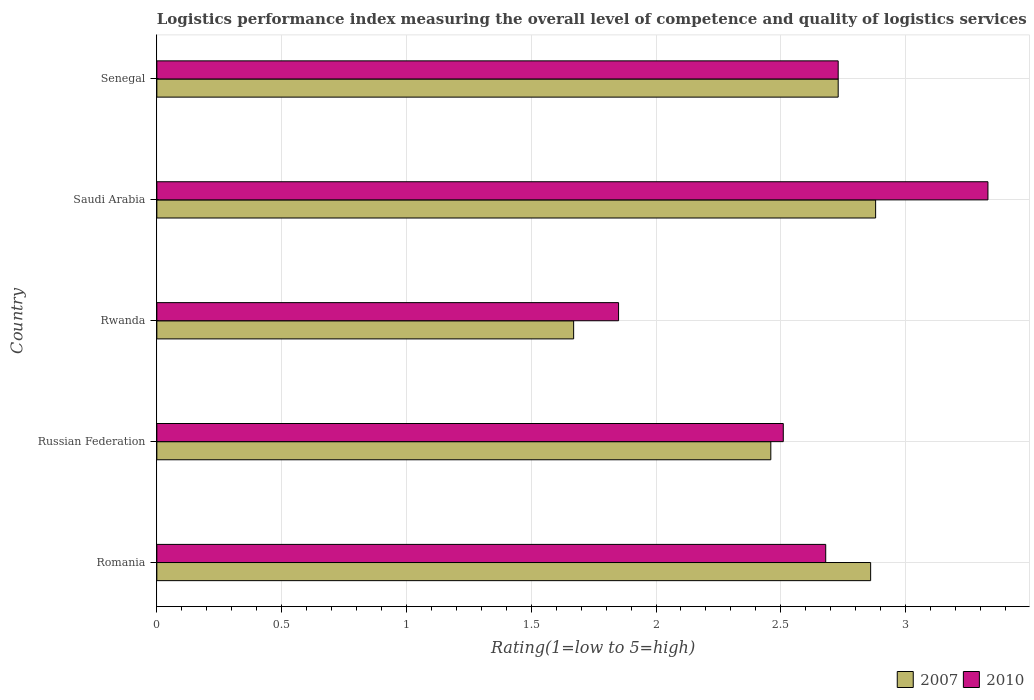How many different coloured bars are there?
Ensure brevity in your answer.  2. Are the number of bars per tick equal to the number of legend labels?
Make the answer very short. Yes. How many bars are there on the 3rd tick from the bottom?
Your answer should be very brief. 2. What is the label of the 1st group of bars from the top?
Give a very brief answer. Senegal. What is the Logistic performance index in 2010 in Saudi Arabia?
Your response must be concise. 3.33. Across all countries, what is the maximum Logistic performance index in 2007?
Your answer should be compact. 2.88. Across all countries, what is the minimum Logistic performance index in 2010?
Your answer should be compact. 1.85. In which country was the Logistic performance index in 2010 maximum?
Provide a succinct answer. Saudi Arabia. In which country was the Logistic performance index in 2010 minimum?
Offer a very short reply. Rwanda. What is the total Logistic performance index in 2007 in the graph?
Provide a succinct answer. 12.6. What is the difference between the Logistic performance index in 2010 in Rwanda and that in Saudi Arabia?
Offer a terse response. -1.48. What is the difference between the Logistic performance index in 2007 in Romania and the Logistic performance index in 2010 in Russian Federation?
Make the answer very short. 0.35. What is the average Logistic performance index in 2007 per country?
Your answer should be very brief. 2.52. What is the difference between the Logistic performance index in 2007 and Logistic performance index in 2010 in Senegal?
Make the answer very short. 0. What is the ratio of the Logistic performance index in 2010 in Saudi Arabia to that in Senegal?
Offer a very short reply. 1.22. Is the Logistic performance index in 2007 in Russian Federation less than that in Rwanda?
Make the answer very short. No. Is the difference between the Logistic performance index in 2007 in Saudi Arabia and Senegal greater than the difference between the Logistic performance index in 2010 in Saudi Arabia and Senegal?
Offer a very short reply. No. What is the difference between the highest and the second highest Logistic performance index in 2010?
Provide a succinct answer. 0.6. What is the difference between the highest and the lowest Logistic performance index in 2007?
Make the answer very short. 1.21. How many bars are there?
Ensure brevity in your answer.  10. Are all the bars in the graph horizontal?
Give a very brief answer. Yes. Does the graph contain grids?
Provide a succinct answer. Yes. Where does the legend appear in the graph?
Offer a very short reply. Bottom right. How many legend labels are there?
Provide a succinct answer. 2. How are the legend labels stacked?
Your response must be concise. Horizontal. What is the title of the graph?
Offer a very short reply. Logistics performance index measuring the overall level of competence and quality of logistics services. Does "2007" appear as one of the legend labels in the graph?
Your answer should be compact. Yes. What is the label or title of the X-axis?
Provide a short and direct response. Rating(1=low to 5=high). What is the label or title of the Y-axis?
Your response must be concise. Country. What is the Rating(1=low to 5=high) of 2007 in Romania?
Your answer should be compact. 2.86. What is the Rating(1=low to 5=high) in 2010 in Romania?
Ensure brevity in your answer.  2.68. What is the Rating(1=low to 5=high) in 2007 in Russian Federation?
Offer a very short reply. 2.46. What is the Rating(1=low to 5=high) in 2010 in Russian Federation?
Make the answer very short. 2.51. What is the Rating(1=low to 5=high) in 2007 in Rwanda?
Your response must be concise. 1.67. What is the Rating(1=low to 5=high) of 2010 in Rwanda?
Your answer should be compact. 1.85. What is the Rating(1=low to 5=high) in 2007 in Saudi Arabia?
Your response must be concise. 2.88. What is the Rating(1=low to 5=high) in 2010 in Saudi Arabia?
Ensure brevity in your answer.  3.33. What is the Rating(1=low to 5=high) in 2007 in Senegal?
Make the answer very short. 2.73. What is the Rating(1=low to 5=high) in 2010 in Senegal?
Make the answer very short. 2.73. Across all countries, what is the maximum Rating(1=low to 5=high) in 2007?
Provide a succinct answer. 2.88. Across all countries, what is the maximum Rating(1=low to 5=high) of 2010?
Your answer should be very brief. 3.33. Across all countries, what is the minimum Rating(1=low to 5=high) of 2007?
Offer a terse response. 1.67. Across all countries, what is the minimum Rating(1=low to 5=high) of 2010?
Keep it short and to the point. 1.85. What is the difference between the Rating(1=low to 5=high) of 2010 in Romania and that in Russian Federation?
Keep it short and to the point. 0.17. What is the difference between the Rating(1=low to 5=high) in 2007 in Romania and that in Rwanda?
Provide a short and direct response. 1.19. What is the difference between the Rating(1=low to 5=high) of 2010 in Romania and that in Rwanda?
Give a very brief answer. 0.83. What is the difference between the Rating(1=low to 5=high) in 2007 in Romania and that in Saudi Arabia?
Ensure brevity in your answer.  -0.02. What is the difference between the Rating(1=low to 5=high) in 2010 in Romania and that in Saudi Arabia?
Ensure brevity in your answer.  -0.65. What is the difference between the Rating(1=low to 5=high) of 2007 in Romania and that in Senegal?
Your answer should be very brief. 0.13. What is the difference between the Rating(1=low to 5=high) in 2010 in Romania and that in Senegal?
Give a very brief answer. -0.05. What is the difference between the Rating(1=low to 5=high) in 2007 in Russian Federation and that in Rwanda?
Make the answer very short. 0.79. What is the difference between the Rating(1=low to 5=high) of 2010 in Russian Federation and that in Rwanda?
Keep it short and to the point. 0.66. What is the difference between the Rating(1=low to 5=high) in 2007 in Russian Federation and that in Saudi Arabia?
Your answer should be very brief. -0.42. What is the difference between the Rating(1=low to 5=high) of 2010 in Russian Federation and that in Saudi Arabia?
Give a very brief answer. -0.82. What is the difference between the Rating(1=low to 5=high) of 2007 in Russian Federation and that in Senegal?
Your answer should be compact. -0.27. What is the difference between the Rating(1=low to 5=high) of 2010 in Russian Federation and that in Senegal?
Provide a short and direct response. -0.22. What is the difference between the Rating(1=low to 5=high) of 2007 in Rwanda and that in Saudi Arabia?
Offer a terse response. -1.21. What is the difference between the Rating(1=low to 5=high) in 2010 in Rwanda and that in Saudi Arabia?
Provide a short and direct response. -1.48. What is the difference between the Rating(1=low to 5=high) in 2007 in Rwanda and that in Senegal?
Your answer should be compact. -1.06. What is the difference between the Rating(1=low to 5=high) in 2010 in Rwanda and that in Senegal?
Make the answer very short. -0.88. What is the difference between the Rating(1=low to 5=high) of 2007 in Saudi Arabia and that in Senegal?
Ensure brevity in your answer.  0.15. What is the difference between the Rating(1=low to 5=high) in 2010 in Saudi Arabia and that in Senegal?
Make the answer very short. 0.6. What is the difference between the Rating(1=low to 5=high) in 2007 in Romania and the Rating(1=low to 5=high) in 2010 in Rwanda?
Provide a succinct answer. 1.01. What is the difference between the Rating(1=low to 5=high) in 2007 in Romania and the Rating(1=low to 5=high) in 2010 in Saudi Arabia?
Give a very brief answer. -0.47. What is the difference between the Rating(1=low to 5=high) of 2007 in Romania and the Rating(1=low to 5=high) of 2010 in Senegal?
Your response must be concise. 0.13. What is the difference between the Rating(1=low to 5=high) of 2007 in Russian Federation and the Rating(1=low to 5=high) of 2010 in Rwanda?
Offer a terse response. 0.61. What is the difference between the Rating(1=low to 5=high) of 2007 in Russian Federation and the Rating(1=low to 5=high) of 2010 in Saudi Arabia?
Ensure brevity in your answer.  -0.87. What is the difference between the Rating(1=low to 5=high) of 2007 in Russian Federation and the Rating(1=low to 5=high) of 2010 in Senegal?
Offer a terse response. -0.27. What is the difference between the Rating(1=low to 5=high) in 2007 in Rwanda and the Rating(1=low to 5=high) in 2010 in Saudi Arabia?
Make the answer very short. -1.66. What is the difference between the Rating(1=low to 5=high) in 2007 in Rwanda and the Rating(1=low to 5=high) in 2010 in Senegal?
Keep it short and to the point. -1.06. What is the average Rating(1=low to 5=high) of 2007 per country?
Your answer should be compact. 2.52. What is the average Rating(1=low to 5=high) in 2010 per country?
Give a very brief answer. 2.62. What is the difference between the Rating(1=low to 5=high) in 2007 and Rating(1=low to 5=high) in 2010 in Romania?
Provide a short and direct response. 0.18. What is the difference between the Rating(1=low to 5=high) in 2007 and Rating(1=low to 5=high) in 2010 in Rwanda?
Your answer should be compact. -0.18. What is the difference between the Rating(1=low to 5=high) of 2007 and Rating(1=low to 5=high) of 2010 in Saudi Arabia?
Provide a succinct answer. -0.45. What is the difference between the Rating(1=low to 5=high) in 2007 and Rating(1=low to 5=high) in 2010 in Senegal?
Keep it short and to the point. 0. What is the ratio of the Rating(1=low to 5=high) in 2007 in Romania to that in Russian Federation?
Your answer should be very brief. 1.16. What is the ratio of the Rating(1=low to 5=high) of 2010 in Romania to that in Russian Federation?
Offer a terse response. 1.07. What is the ratio of the Rating(1=low to 5=high) in 2007 in Romania to that in Rwanda?
Offer a very short reply. 1.71. What is the ratio of the Rating(1=low to 5=high) in 2010 in Romania to that in Rwanda?
Provide a short and direct response. 1.45. What is the ratio of the Rating(1=low to 5=high) of 2007 in Romania to that in Saudi Arabia?
Make the answer very short. 0.99. What is the ratio of the Rating(1=low to 5=high) in 2010 in Romania to that in Saudi Arabia?
Ensure brevity in your answer.  0.8. What is the ratio of the Rating(1=low to 5=high) in 2007 in Romania to that in Senegal?
Offer a terse response. 1.05. What is the ratio of the Rating(1=low to 5=high) of 2010 in Romania to that in Senegal?
Your response must be concise. 0.98. What is the ratio of the Rating(1=low to 5=high) of 2007 in Russian Federation to that in Rwanda?
Keep it short and to the point. 1.47. What is the ratio of the Rating(1=low to 5=high) of 2010 in Russian Federation to that in Rwanda?
Your response must be concise. 1.36. What is the ratio of the Rating(1=low to 5=high) of 2007 in Russian Federation to that in Saudi Arabia?
Your answer should be compact. 0.85. What is the ratio of the Rating(1=low to 5=high) in 2010 in Russian Federation to that in Saudi Arabia?
Ensure brevity in your answer.  0.75. What is the ratio of the Rating(1=low to 5=high) in 2007 in Russian Federation to that in Senegal?
Keep it short and to the point. 0.9. What is the ratio of the Rating(1=low to 5=high) in 2010 in Russian Federation to that in Senegal?
Ensure brevity in your answer.  0.92. What is the ratio of the Rating(1=low to 5=high) of 2007 in Rwanda to that in Saudi Arabia?
Your answer should be compact. 0.58. What is the ratio of the Rating(1=low to 5=high) in 2010 in Rwanda to that in Saudi Arabia?
Your answer should be compact. 0.56. What is the ratio of the Rating(1=low to 5=high) in 2007 in Rwanda to that in Senegal?
Give a very brief answer. 0.61. What is the ratio of the Rating(1=low to 5=high) in 2010 in Rwanda to that in Senegal?
Your answer should be very brief. 0.68. What is the ratio of the Rating(1=low to 5=high) in 2007 in Saudi Arabia to that in Senegal?
Provide a short and direct response. 1.05. What is the ratio of the Rating(1=low to 5=high) in 2010 in Saudi Arabia to that in Senegal?
Give a very brief answer. 1.22. What is the difference between the highest and the second highest Rating(1=low to 5=high) in 2010?
Provide a short and direct response. 0.6. What is the difference between the highest and the lowest Rating(1=low to 5=high) of 2007?
Provide a short and direct response. 1.21. What is the difference between the highest and the lowest Rating(1=low to 5=high) of 2010?
Give a very brief answer. 1.48. 